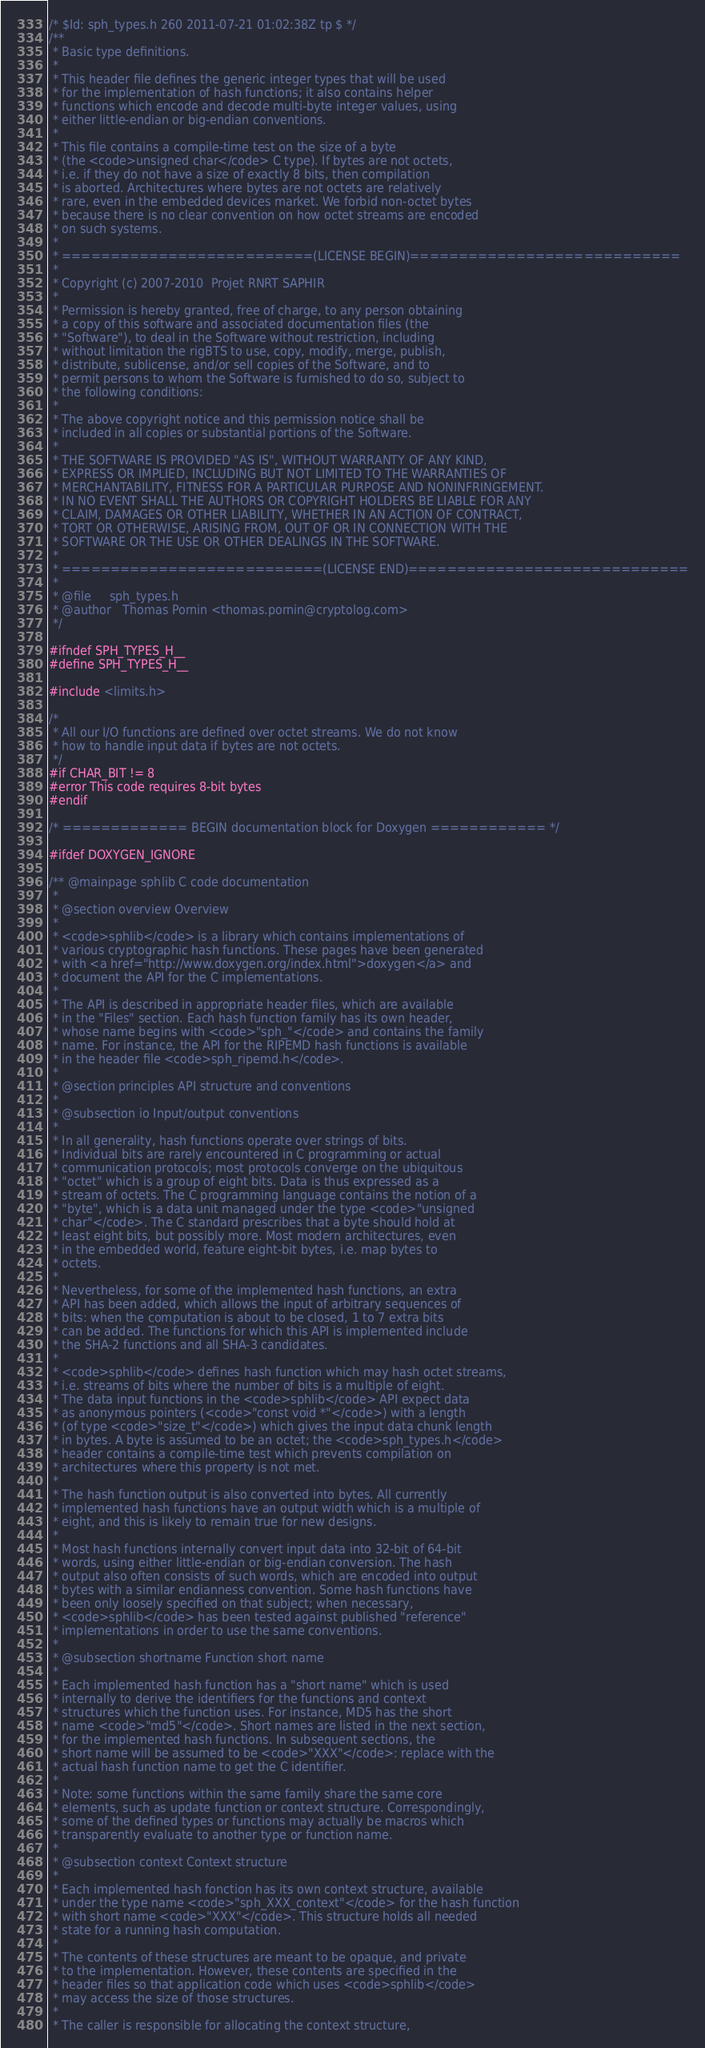<code> <loc_0><loc_0><loc_500><loc_500><_C_>/* $Id: sph_types.h 260 2011-07-21 01:02:38Z tp $ */
/**
 * Basic type definitions.
 *
 * This header file defines the generic integer types that will be used
 * for the implementation of hash functions; it also contains helper
 * functions which encode and decode multi-byte integer values, using
 * either little-endian or big-endian conventions.
 *
 * This file contains a compile-time test on the size of a byte
 * (the <code>unsigned char</code> C type). If bytes are not octets,
 * i.e. if they do not have a size of exactly 8 bits, then compilation
 * is aborted. Architectures where bytes are not octets are relatively
 * rare, even in the embedded devices market. We forbid non-octet bytes
 * because there is no clear convention on how octet streams are encoded
 * on such systems.
 *
 * ==========================(LICENSE BEGIN)============================
 *
 * Copyright (c) 2007-2010  Projet RNRT SAPHIR
 * 
 * Permission is hereby granted, free of charge, to any person obtaining
 * a copy of this software and associated documentation files (the
 * "Software"), to deal in the Software without restriction, including
 * without limitation the rigBTS to use, copy, modify, merge, publish,
 * distribute, sublicense, and/or sell copies of the Software, and to
 * permit persons to whom the Software is furnished to do so, subject to
 * the following conditions:
 * 
 * The above copyright notice and this permission notice shall be
 * included in all copies or substantial portions of the Software.
 * 
 * THE SOFTWARE IS PROVIDED "AS IS", WITHOUT WARRANTY OF ANY KIND,
 * EXPRESS OR IMPLIED, INCLUDING BUT NOT LIMITED TO THE WARRANTIES OF
 * MERCHANTABILITY, FITNESS FOR A PARTICULAR PURPOSE AND NONINFRINGEMENT.
 * IN NO EVENT SHALL THE AUTHORS OR COPYRIGHT HOLDERS BE LIABLE FOR ANY
 * CLAIM, DAMAGES OR OTHER LIABILITY, WHETHER IN AN ACTION OF CONTRACT,
 * TORT OR OTHERWISE, ARISING FROM, OUT OF OR IN CONNECTION WITH THE
 * SOFTWARE OR THE USE OR OTHER DEALINGS IN THE SOFTWARE.
 *
 * ===========================(LICENSE END)=============================
 *
 * @file     sph_types.h
 * @author   Thomas Pornin <thomas.pornin@cryptolog.com>
 */

#ifndef SPH_TYPES_H__
#define SPH_TYPES_H__

#include <limits.h>

/*
 * All our I/O functions are defined over octet streams. We do not know
 * how to handle input data if bytes are not octets.
 */
#if CHAR_BIT != 8
#error This code requires 8-bit bytes
#endif

/* ============= BEGIN documentation block for Doxygen ============ */

#ifdef DOXYGEN_IGNORE

/** @mainpage sphlib C code documentation
 *
 * @section overview Overview
 *
 * <code>sphlib</code> is a library which contains implementations of
 * various cryptographic hash functions. These pages have been generated
 * with <a href="http://www.doxygen.org/index.html">doxygen</a> and
 * document the API for the C implementations.
 *
 * The API is described in appropriate header files, which are available
 * in the "Files" section. Each hash function family has its own header,
 * whose name begins with <code>"sph_"</code> and contains the family
 * name. For instance, the API for the RIPEMD hash functions is available
 * in the header file <code>sph_ripemd.h</code>.
 *
 * @section principles API structure and conventions
 *
 * @subsection io Input/output conventions
 *
 * In all generality, hash functions operate over strings of bits.
 * Individual bits are rarely encountered in C programming or actual
 * communication protocols; most protocols converge on the ubiquitous
 * "octet" which is a group of eight bits. Data is thus expressed as a
 * stream of octets. The C programming language contains the notion of a
 * "byte", which is a data unit managed under the type <code>"unsigned
 * char"</code>. The C standard prescribes that a byte should hold at
 * least eight bits, but possibly more. Most modern architectures, even
 * in the embedded world, feature eight-bit bytes, i.e. map bytes to
 * octets.
 *
 * Nevertheless, for some of the implemented hash functions, an extra
 * API has been added, which allows the input of arbitrary sequences of
 * bits: when the computation is about to be closed, 1 to 7 extra bits
 * can be added. The functions for which this API is implemented include
 * the SHA-2 functions and all SHA-3 candidates.
 *
 * <code>sphlib</code> defines hash function which may hash octet streams,
 * i.e. streams of bits where the number of bits is a multiple of eight.
 * The data input functions in the <code>sphlib</code> API expect data
 * as anonymous pointers (<code>"const void *"</code>) with a length
 * (of type <code>"size_t"</code>) which gives the input data chunk length
 * in bytes. A byte is assumed to be an octet; the <code>sph_types.h</code>
 * header contains a compile-time test which prevents compilation on
 * architectures where this property is not met.
 *
 * The hash function output is also converted into bytes. All currently
 * implemented hash functions have an output width which is a multiple of
 * eight, and this is likely to remain true for new designs.
 *
 * Most hash functions internally convert input data into 32-bit of 64-bit
 * words, using either little-endian or big-endian conversion. The hash
 * output also often consists of such words, which are encoded into output
 * bytes with a similar endianness convention. Some hash functions have
 * been only loosely specified on that subject; when necessary,
 * <code>sphlib</code> has been tested against published "reference"
 * implementations in order to use the same conventions.
 *
 * @subsection shortname Function short name
 *
 * Each implemented hash function has a "short name" which is used
 * internally to derive the identifiers for the functions and context
 * structures which the function uses. For instance, MD5 has the short
 * name <code>"md5"</code>. Short names are listed in the next section,
 * for the implemented hash functions. In subsequent sections, the
 * short name will be assumed to be <code>"XXX"</code>: replace with the
 * actual hash function name to get the C identifier.
 *
 * Note: some functions within the same family share the same core
 * elements, such as update function or context structure. Correspondingly,
 * some of the defined types or functions may actually be macros which
 * transparently evaluate to another type or function name.
 *
 * @subsection context Context structure
 *
 * Each implemented hash fonction has its own context structure, available
 * under the type name <code>"sph_XXX_context"</code> for the hash function
 * with short name <code>"XXX"</code>. This structure holds all needed
 * state for a running hash computation.
 *
 * The contents of these structures are meant to be opaque, and private
 * to the implementation. However, these contents are specified in the
 * header files so that application code which uses <code>sphlib</code>
 * may access the size of those structures.
 *
 * The caller is responsible for allocating the context structure,</code> 